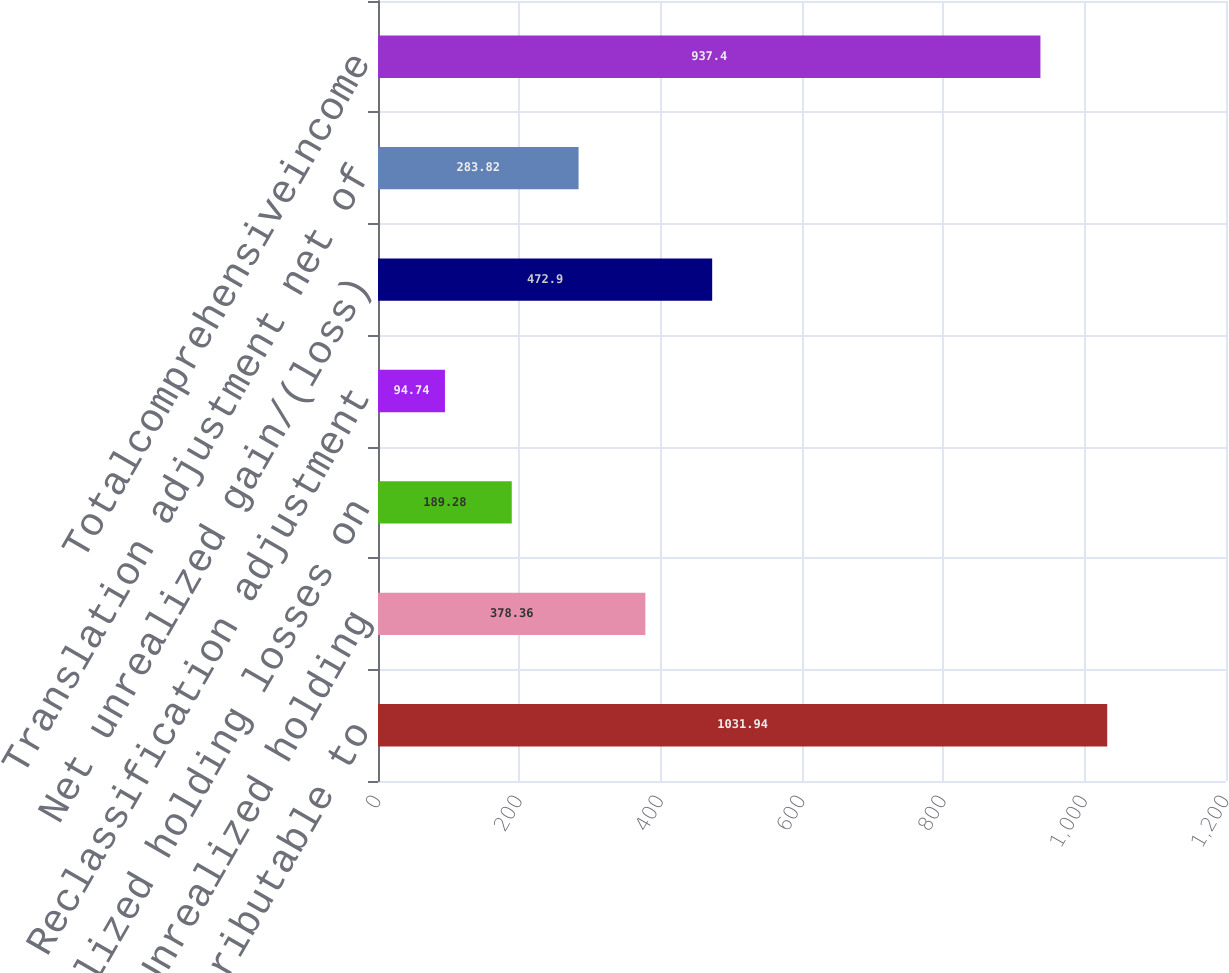Convert chart to OTSL. <chart><loc_0><loc_0><loc_500><loc_500><bar_chart><fcel>Net earnings attributable to<fcel>Unrealized holding<fcel>Unrealized holding losses on<fcel>Reclassification adjustment<fcel>Net unrealized gain/(loss)<fcel>Translation adjustment net of<fcel>Totalcomprehensiveincome<nl><fcel>1031.94<fcel>378.36<fcel>189.28<fcel>94.74<fcel>472.9<fcel>283.82<fcel>937.4<nl></chart> 